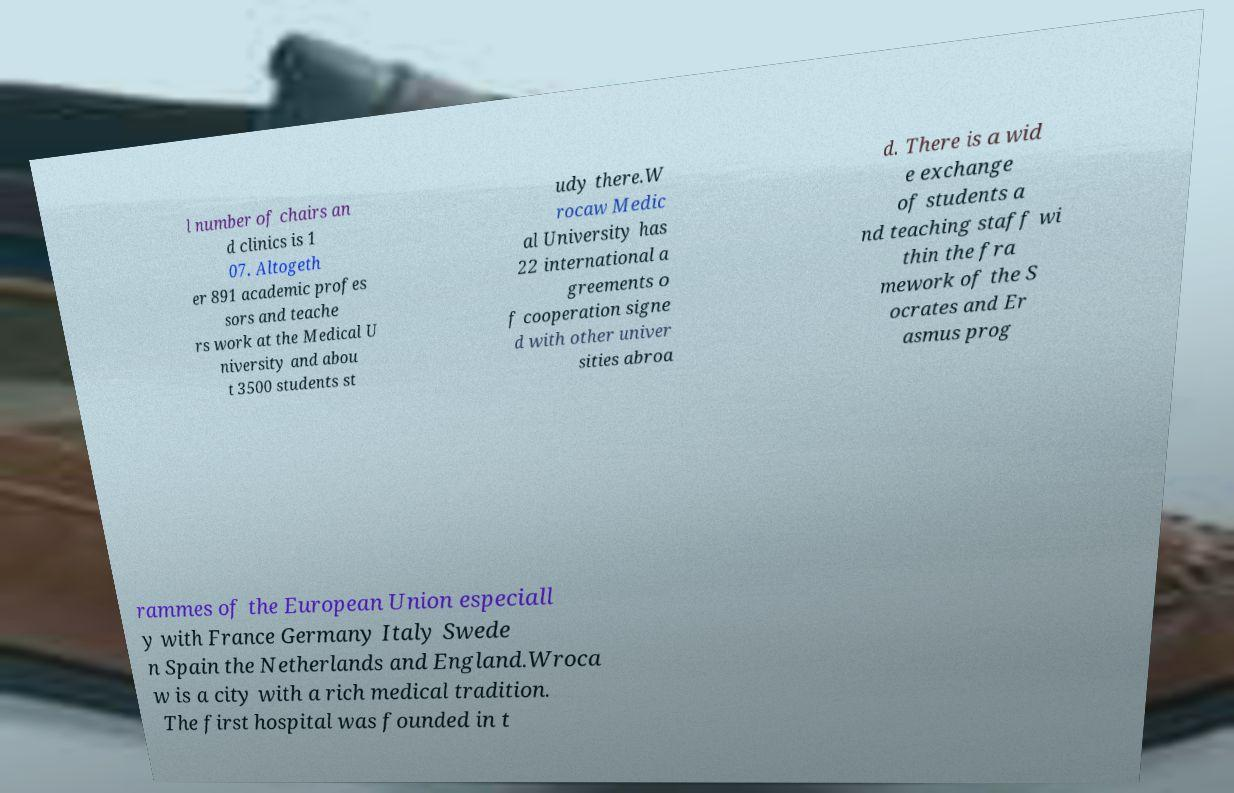Could you assist in decoding the text presented in this image and type it out clearly? l number of chairs an d clinics is 1 07. Altogeth er 891 academic profes sors and teache rs work at the Medical U niversity and abou t 3500 students st udy there.W rocaw Medic al University has 22 international a greements o f cooperation signe d with other univer sities abroa d. There is a wid e exchange of students a nd teaching staff wi thin the fra mework of the S ocrates and Er asmus prog rammes of the European Union especiall y with France Germany Italy Swede n Spain the Netherlands and England.Wroca w is a city with a rich medical tradition. The first hospital was founded in t 